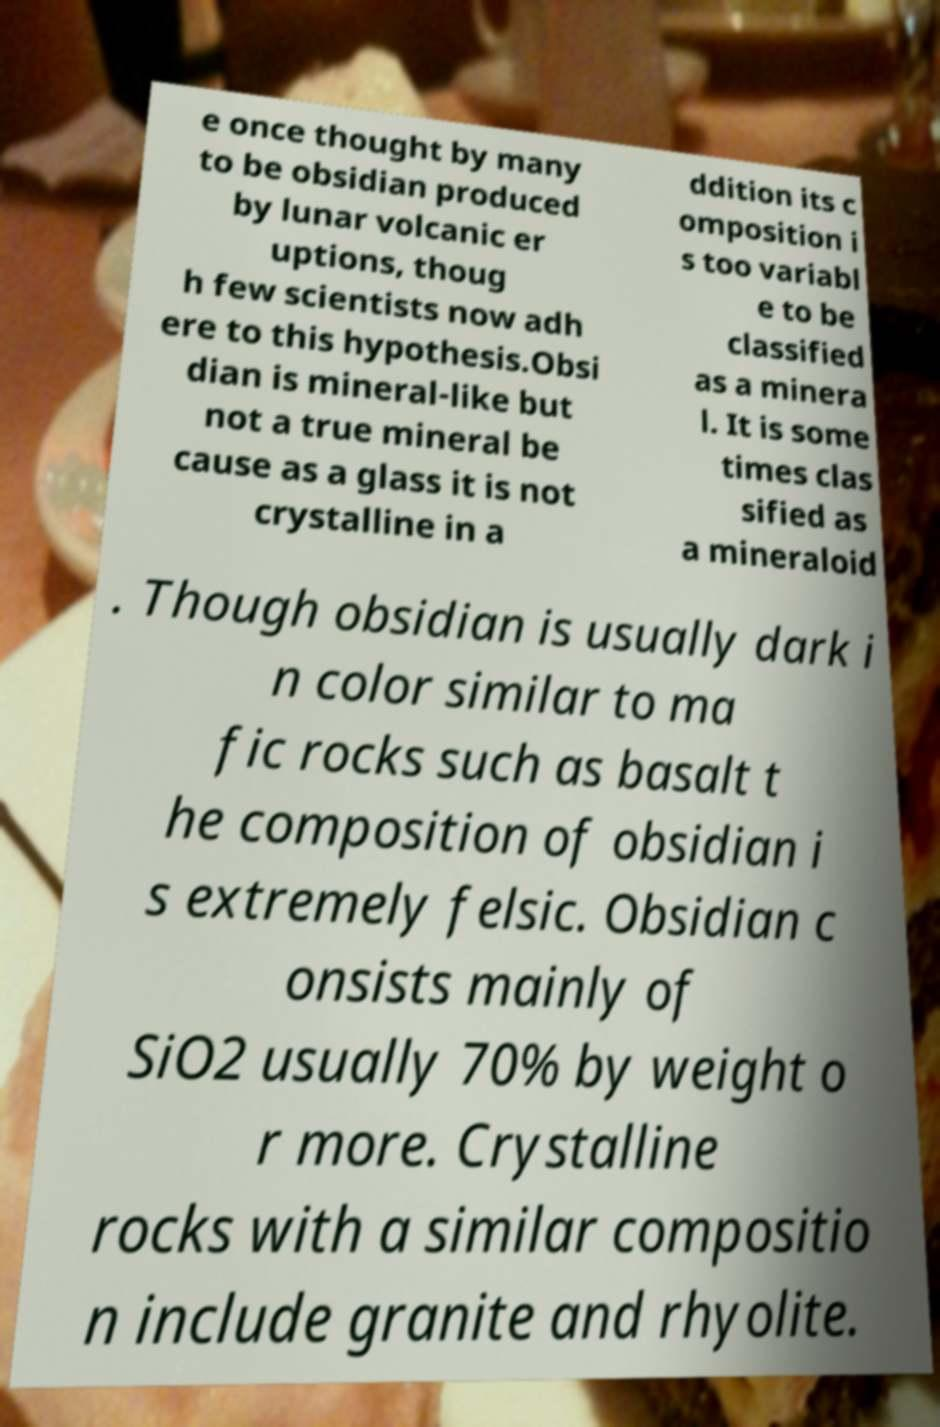Please identify and transcribe the text found in this image. e once thought by many to be obsidian produced by lunar volcanic er uptions, thoug h few scientists now adh ere to this hypothesis.Obsi dian is mineral-like but not a true mineral be cause as a glass it is not crystalline in a ddition its c omposition i s too variabl e to be classified as a minera l. It is some times clas sified as a mineraloid . Though obsidian is usually dark i n color similar to ma fic rocks such as basalt t he composition of obsidian i s extremely felsic. Obsidian c onsists mainly of SiO2 usually 70% by weight o r more. Crystalline rocks with a similar compositio n include granite and rhyolite. 